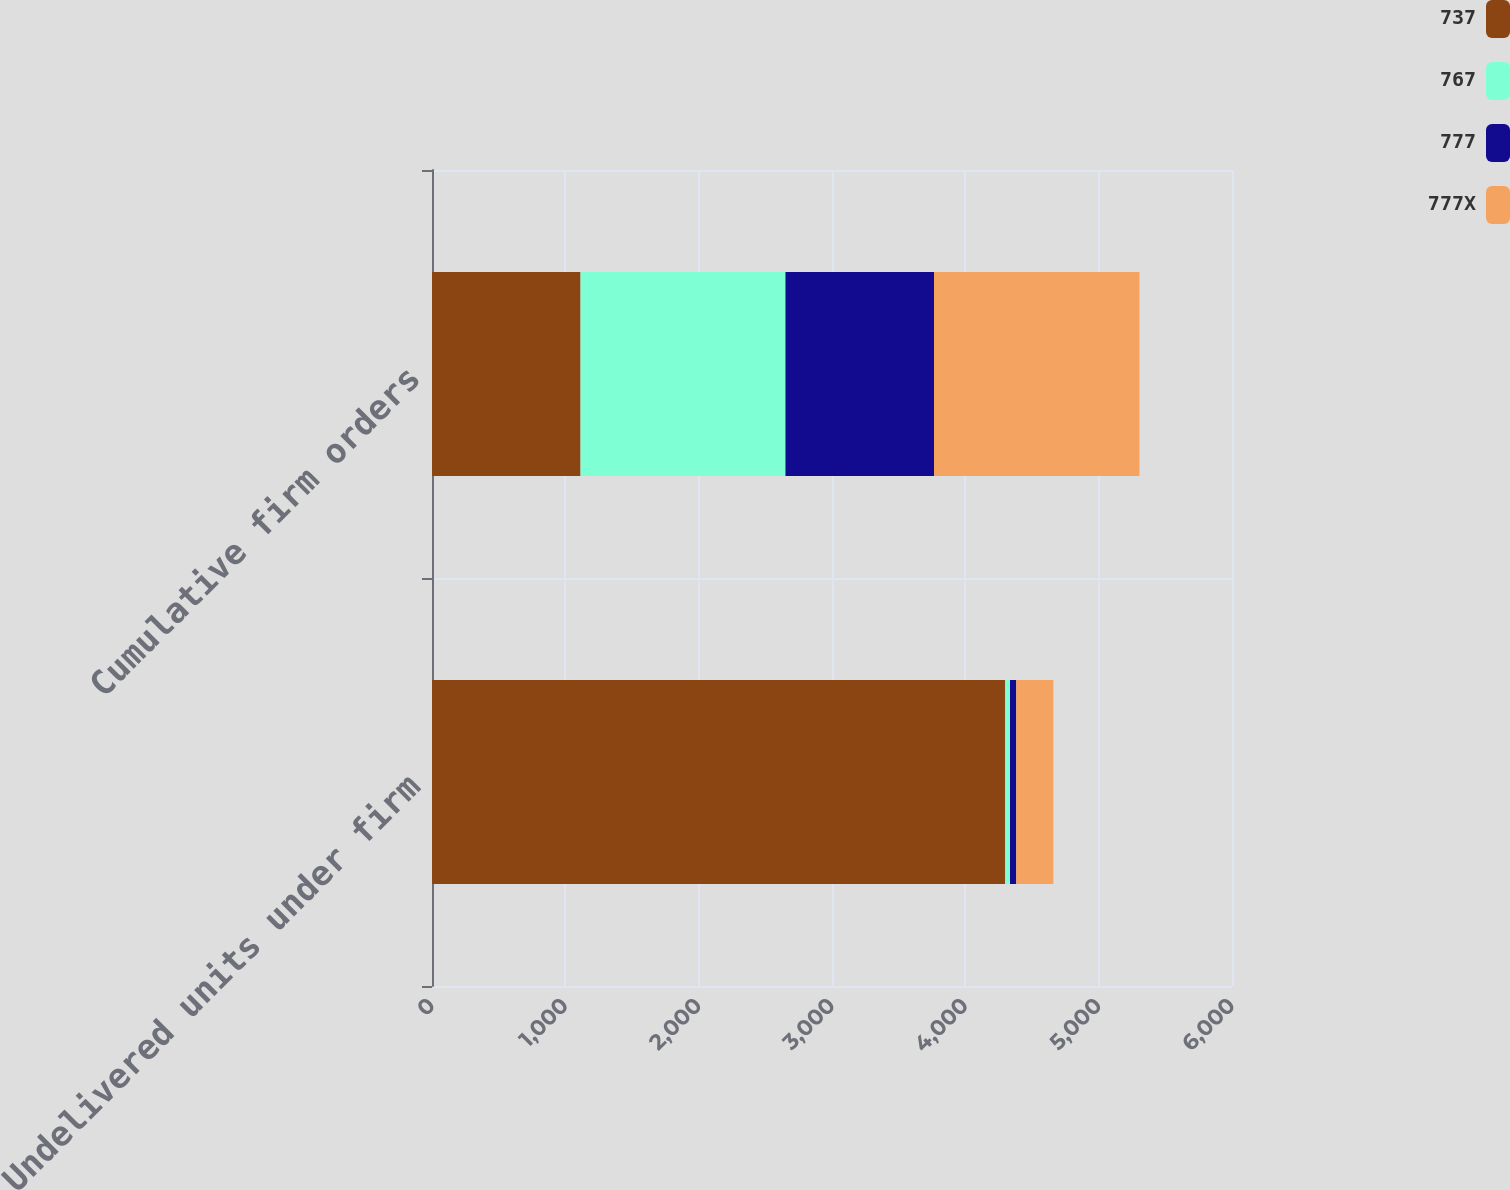Convert chart to OTSL. <chart><loc_0><loc_0><loc_500><loc_500><stacked_bar_chart><ecel><fcel>Undelivered units under firm<fcel>Cumulative firm orders<nl><fcel>737<fcel>4299<fcel>1114<nl><fcel>767<fcel>36<fcel>1537<nl><fcel>777<fcel>47<fcel>1114<nl><fcel>777X<fcel>278<fcel>1541<nl></chart> 